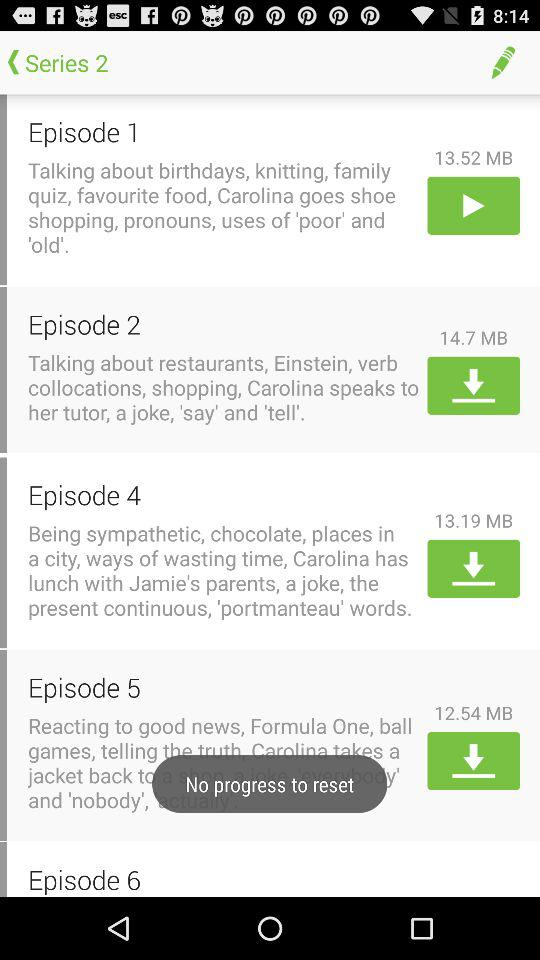How much memory space does "Episode 2" require for download? The memory space required for download by "Episode 2" is 14.7 MB. 